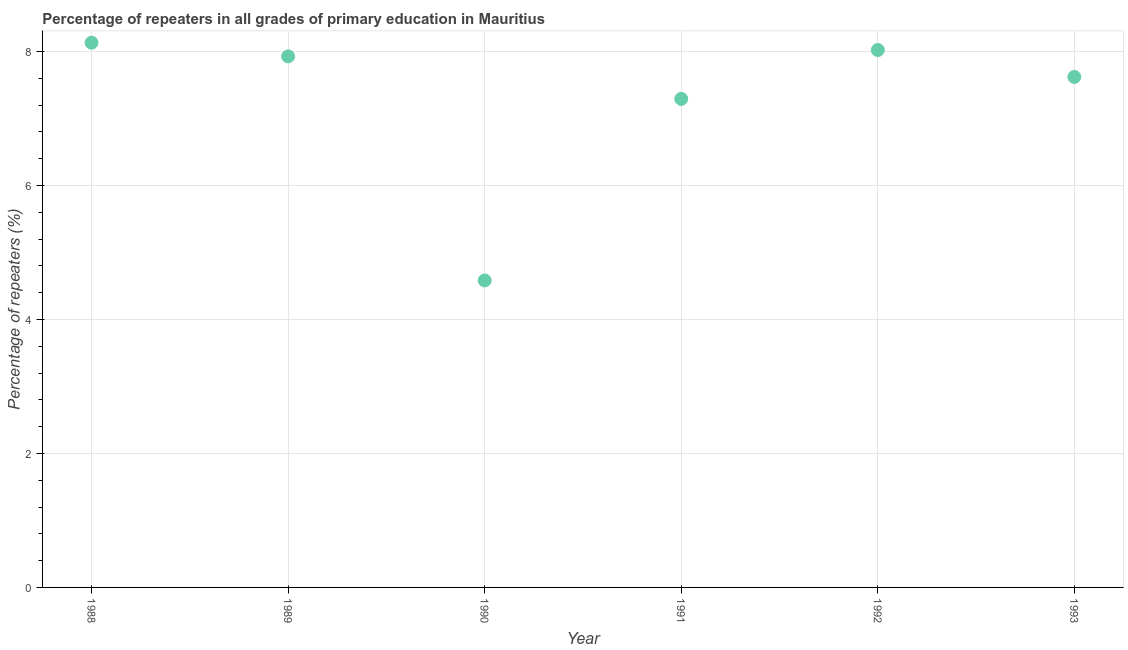What is the percentage of repeaters in primary education in 1992?
Your response must be concise. 8.02. Across all years, what is the maximum percentage of repeaters in primary education?
Offer a terse response. 8.13. Across all years, what is the minimum percentage of repeaters in primary education?
Keep it short and to the point. 4.58. In which year was the percentage of repeaters in primary education maximum?
Give a very brief answer. 1988. What is the sum of the percentage of repeaters in primary education?
Ensure brevity in your answer.  43.59. What is the difference between the percentage of repeaters in primary education in 1988 and 1989?
Your answer should be compact. 0.2. What is the average percentage of repeaters in primary education per year?
Give a very brief answer. 7.26. What is the median percentage of repeaters in primary education?
Your answer should be very brief. 7.78. In how many years, is the percentage of repeaters in primary education greater than 4.4 %?
Ensure brevity in your answer.  6. What is the ratio of the percentage of repeaters in primary education in 1989 to that in 1991?
Ensure brevity in your answer.  1.09. Is the percentage of repeaters in primary education in 1991 less than that in 1992?
Your response must be concise. Yes. Is the difference between the percentage of repeaters in primary education in 1989 and 1991 greater than the difference between any two years?
Your response must be concise. No. What is the difference between the highest and the second highest percentage of repeaters in primary education?
Ensure brevity in your answer.  0.11. What is the difference between the highest and the lowest percentage of repeaters in primary education?
Offer a terse response. 3.55. How many dotlines are there?
Provide a succinct answer. 1. How many years are there in the graph?
Offer a terse response. 6. Does the graph contain grids?
Ensure brevity in your answer.  Yes. What is the title of the graph?
Give a very brief answer. Percentage of repeaters in all grades of primary education in Mauritius. What is the label or title of the X-axis?
Offer a very short reply. Year. What is the label or title of the Y-axis?
Give a very brief answer. Percentage of repeaters (%). What is the Percentage of repeaters (%) in 1988?
Provide a short and direct response. 8.13. What is the Percentage of repeaters (%) in 1989?
Your response must be concise. 7.93. What is the Percentage of repeaters (%) in 1990?
Provide a succinct answer. 4.58. What is the Percentage of repeaters (%) in 1991?
Your answer should be very brief. 7.29. What is the Percentage of repeaters (%) in 1992?
Your answer should be compact. 8.02. What is the Percentage of repeaters (%) in 1993?
Keep it short and to the point. 7.62. What is the difference between the Percentage of repeaters (%) in 1988 and 1989?
Provide a succinct answer. 0.2. What is the difference between the Percentage of repeaters (%) in 1988 and 1990?
Your answer should be compact. 3.55. What is the difference between the Percentage of repeaters (%) in 1988 and 1991?
Make the answer very short. 0.84. What is the difference between the Percentage of repeaters (%) in 1988 and 1992?
Ensure brevity in your answer.  0.11. What is the difference between the Percentage of repeaters (%) in 1988 and 1993?
Offer a very short reply. 0.51. What is the difference between the Percentage of repeaters (%) in 1989 and 1990?
Provide a succinct answer. 3.35. What is the difference between the Percentage of repeaters (%) in 1989 and 1991?
Your response must be concise. 0.63. What is the difference between the Percentage of repeaters (%) in 1989 and 1992?
Your answer should be very brief. -0.1. What is the difference between the Percentage of repeaters (%) in 1989 and 1993?
Offer a terse response. 0.31. What is the difference between the Percentage of repeaters (%) in 1990 and 1991?
Give a very brief answer. -2.71. What is the difference between the Percentage of repeaters (%) in 1990 and 1992?
Provide a succinct answer. -3.44. What is the difference between the Percentage of repeaters (%) in 1990 and 1993?
Make the answer very short. -3.04. What is the difference between the Percentage of repeaters (%) in 1991 and 1992?
Give a very brief answer. -0.73. What is the difference between the Percentage of repeaters (%) in 1991 and 1993?
Your response must be concise. -0.33. What is the difference between the Percentage of repeaters (%) in 1992 and 1993?
Keep it short and to the point. 0.4. What is the ratio of the Percentage of repeaters (%) in 1988 to that in 1989?
Your answer should be compact. 1.03. What is the ratio of the Percentage of repeaters (%) in 1988 to that in 1990?
Ensure brevity in your answer.  1.77. What is the ratio of the Percentage of repeaters (%) in 1988 to that in 1991?
Keep it short and to the point. 1.11. What is the ratio of the Percentage of repeaters (%) in 1988 to that in 1992?
Keep it short and to the point. 1.01. What is the ratio of the Percentage of repeaters (%) in 1988 to that in 1993?
Your answer should be very brief. 1.07. What is the ratio of the Percentage of repeaters (%) in 1989 to that in 1990?
Ensure brevity in your answer.  1.73. What is the ratio of the Percentage of repeaters (%) in 1989 to that in 1991?
Keep it short and to the point. 1.09. What is the ratio of the Percentage of repeaters (%) in 1989 to that in 1993?
Offer a very short reply. 1.04. What is the ratio of the Percentage of repeaters (%) in 1990 to that in 1991?
Offer a terse response. 0.63. What is the ratio of the Percentage of repeaters (%) in 1990 to that in 1992?
Give a very brief answer. 0.57. What is the ratio of the Percentage of repeaters (%) in 1990 to that in 1993?
Keep it short and to the point. 0.6. What is the ratio of the Percentage of repeaters (%) in 1991 to that in 1992?
Your answer should be very brief. 0.91. What is the ratio of the Percentage of repeaters (%) in 1991 to that in 1993?
Ensure brevity in your answer.  0.96. What is the ratio of the Percentage of repeaters (%) in 1992 to that in 1993?
Give a very brief answer. 1.05. 